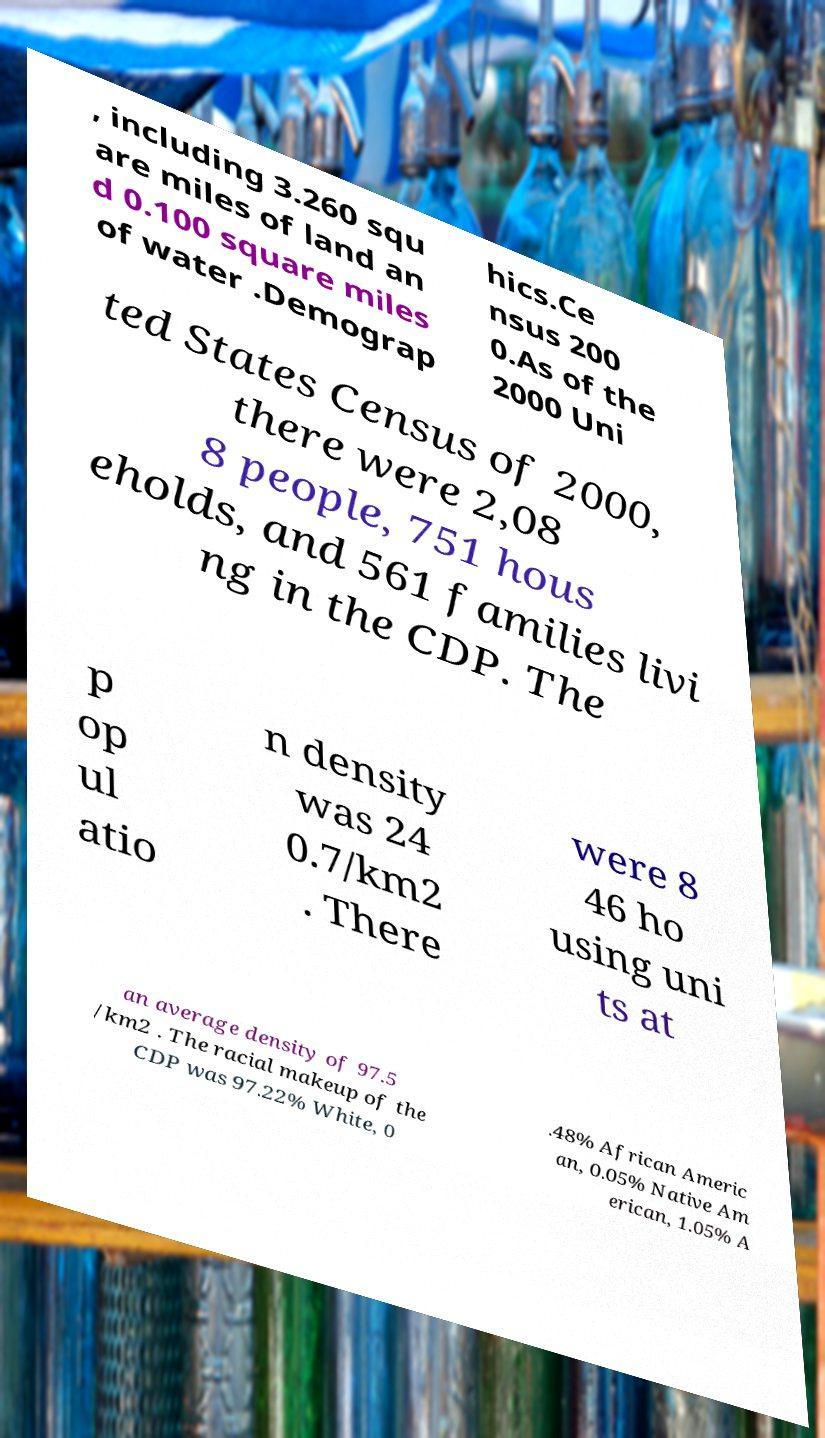What messages or text are displayed in this image? I need them in a readable, typed format. , including 3.260 squ are miles of land an d 0.100 square miles of water .Demograp hics.Ce nsus 200 0.As of the 2000 Uni ted States Census of 2000, there were 2,08 8 people, 751 hous eholds, and 561 families livi ng in the CDP. The p op ul atio n density was 24 0.7/km2 . There were 8 46 ho using uni ts at an average density of 97.5 /km2 . The racial makeup of the CDP was 97.22% White, 0 .48% African Americ an, 0.05% Native Am erican, 1.05% A 